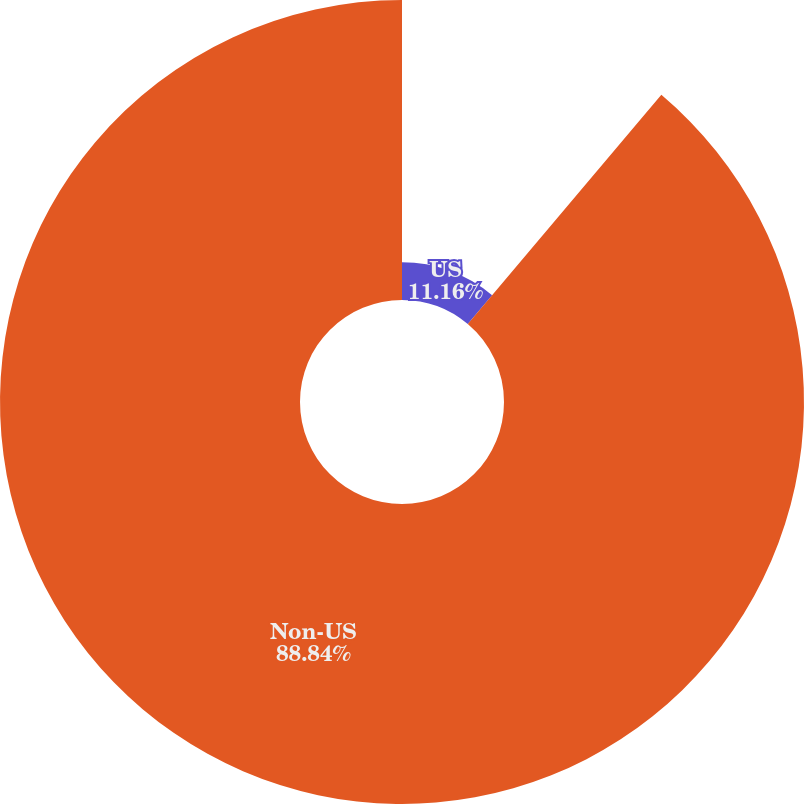Convert chart. <chart><loc_0><loc_0><loc_500><loc_500><pie_chart><fcel>US<fcel>Non-US<nl><fcel>11.16%<fcel>88.84%<nl></chart> 